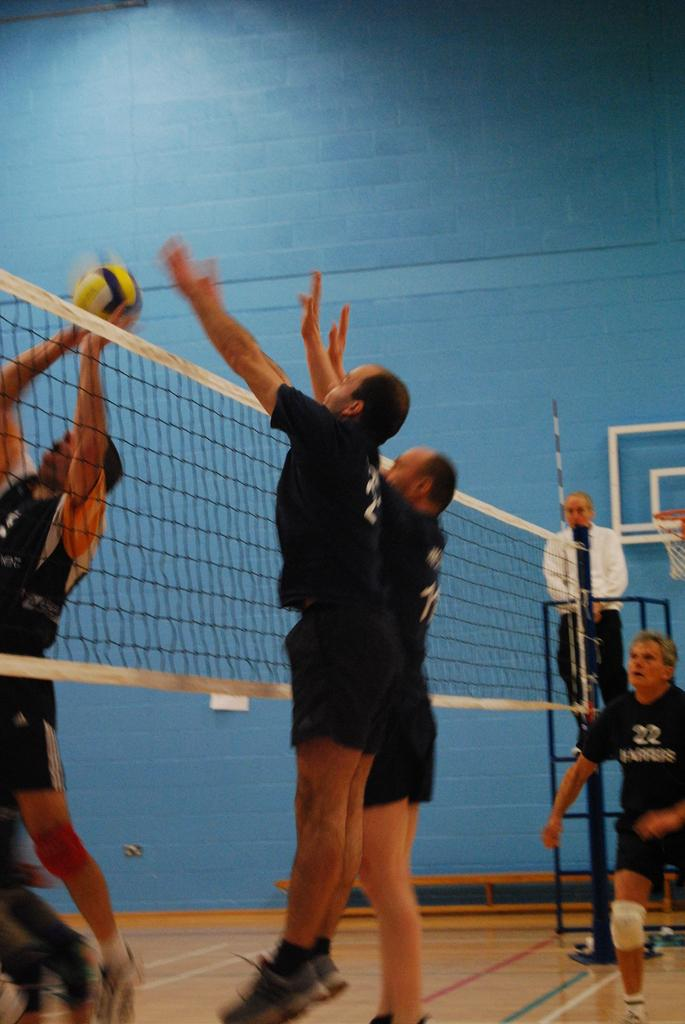What activity are the people in the image engaged in? The people in the image are playing volleyball. What is used to separate the teams in the game? There is a volleyball net in the image. What can be seen in the background of the image? There is a wall in the background of the image. What type of animal can be seen playing the drums in the image? There are no animals or drums present in the image; it features people playing volleyball with a volleyball net and a wall in the background. 